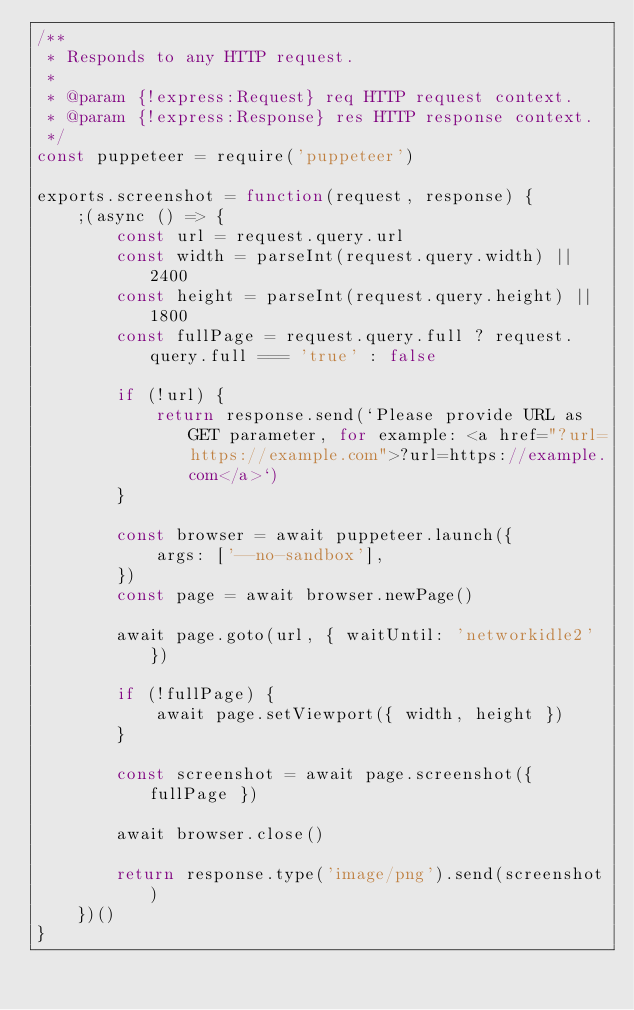Convert code to text. <code><loc_0><loc_0><loc_500><loc_500><_JavaScript_>/**
 * Responds to any HTTP request.
 *
 * @param {!express:Request} req HTTP request context.
 * @param {!express:Response} res HTTP response context.
 */
const puppeteer = require('puppeteer')

exports.screenshot = function(request, response) {
	;(async () => {
		const url = request.query.url
		const width = parseInt(request.query.width) || 2400
		const height = parseInt(request.query.height) || 1800
		const fullPage = request.query.full ? request.query.full === 'true' : false

		if (!url) {
			return response.send(`Please provide URL as GET parameter, for example: <a href="?url=https://example.com">?url=https://example.com</a>`)
		}

		const browser = await puppeteer.launch({
			args: ['--no-sandbox'],
		})
		const page = await browser.newPage()

		await page.goto(url, { waitUntil: 'networkidle2' })

		if (!fullPage) {
			await page.setViewport({ width, height })
		}

		const screenshot = await page.screenshot({ fullPage })

		await browser.close()

		return response.type('image/png').send(screenshot)
	})()
}
</code> 